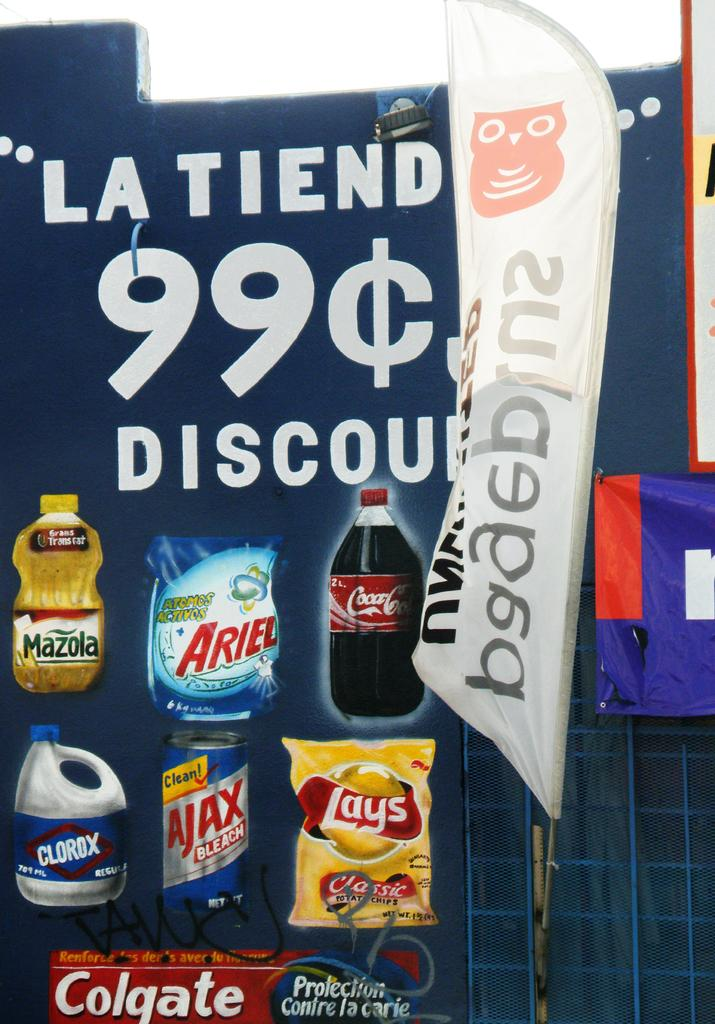What is the main structure visible in the image? There is a hoarding in the image. What else can be seen on the hoarding? There are banners in the image. What type of products are displayed on the hoarding? The hoarding contains bottles and packets. Is there any text present on the hoarding? Yes, there is text on the hoarding. What type of musical instrument can be seen hanging from the hoarding in the image? There is no musical instrument hanging from the hoarding in the image. Can you hear the sound of a bell in the image? There is no sound or bell present in the image; it is a static visual representation. 